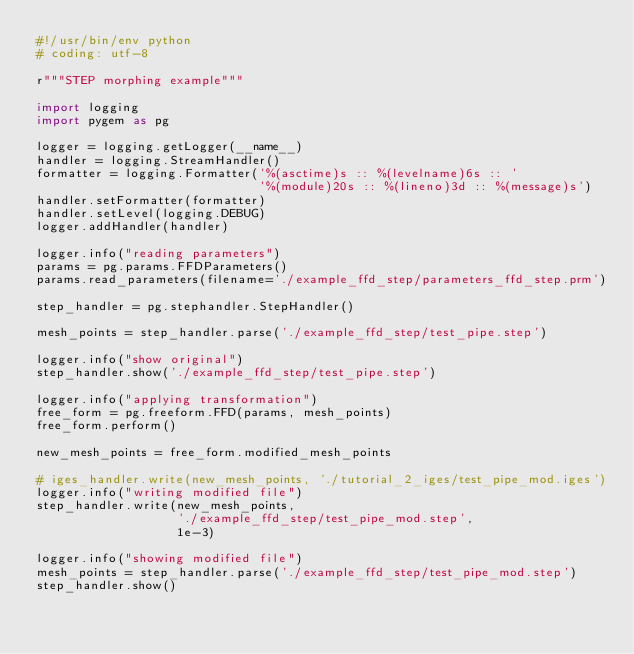<code> <loc_0><loc_0><loc_500><loc_500><_Python_>#!/usr/bin/env python
# coding: utf-8

r"""STEP morphing example"""

import logging
import pygem as pg

logger = logging.getLogger(__name__)
handler = logging.StreamHandler()
formatter = logging.Formatter('%(asctime)s :: %(levelname)6s :: '
                              '%(module)20s :: %(lineno)3d :: %(message)s')
handler.setFormatter(formatter)
handler.setLevel(logging.DEBUG)
logger.addHandler(handler)

logger.info("reading parameters")
params = pg.params.FFDParameters()
params.read_parameters(filename='./example_ffd_step/parameters_ffd_step.prm')

step_handler = pg.stephandler.StepHandler()

mesh_points = step_handler.parse('./example_ffd_step/test_pipe.step')

logger.info("show original")
step_handler.show('./example_ffd_step/test_pipe.step')

logger.info("applying transformation")
free_form = pg.freeform.FFD(params, mesh_points)
free_form.perform()

new_mesh_points = free_form.modified_mesh_points

# iges_handler.write(new_mesh_points, './tutorial_2_iges/test_pipe_mod.iges')
logger.info("writing modified file")
step_handler.write(new_mesh_points,
                   './example_ffd_step/test_pipe_mod.step',
                   1e-3)

logger.info("showing modified file")
mesh_points = step_handler.parse('./example_ffd_step/test_pipe_mod.step')
step_handler.show()
</code> 